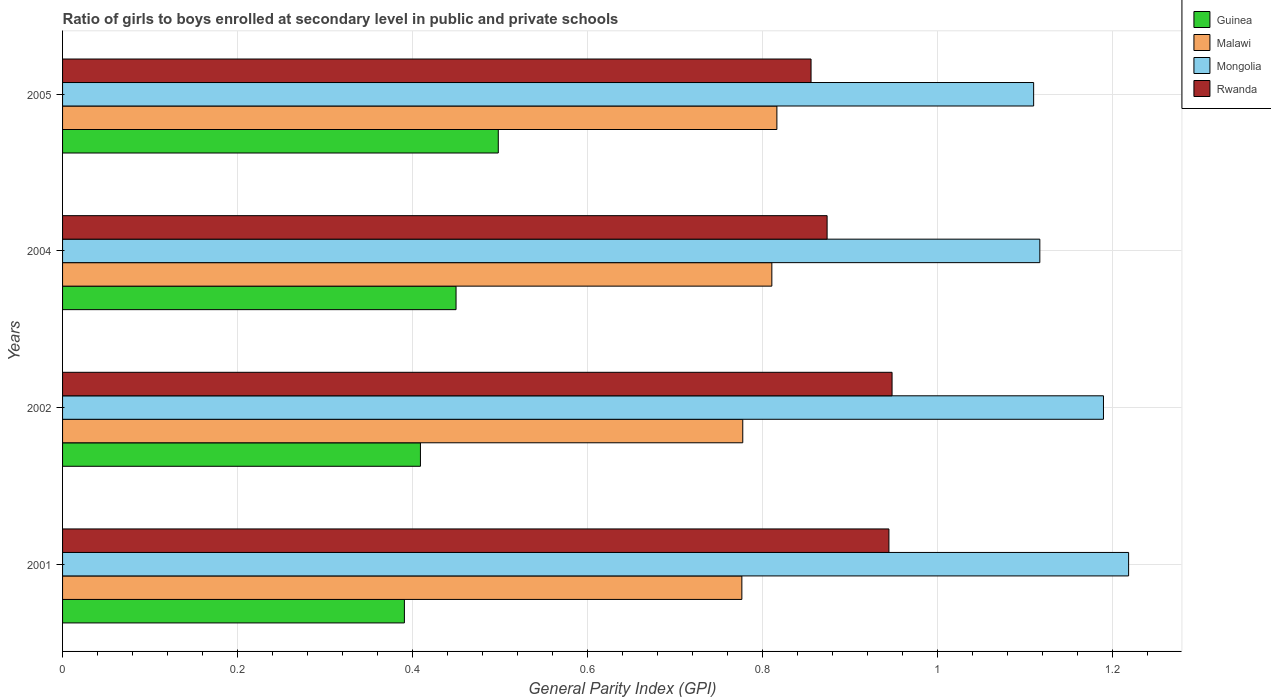How many different coloured bars are there?
Your response must be concise. 4. Are the number of bars per tick equal to the number of legend labels?
Your answer should be compact. Yes. How many bars are there on the 3rd tick from the top?
Make the answer very short. 4. In how many cases, is the number of bars for a given year not equal to the number of legend labels?
Provide a short and direct response. 0. What is the general parity index in Guinea in 2005?
Make the answer very short. 0.5. Across all years, what is the maximum general parity index in Mongolia?
Provide a short and direct response. 1.22. Across all years, what is the minimum general parity index in Mongolia?
Your answer should be very brief. 1.11. In which year was the general parity index in Guinea maximum?
Ensure brevity in your answer.  2005. What is the total general parity index in Guinea in the graph?
Keep it short and to the point. 1.75. What is the difference between the general parity index in Guinea in 2002 and that in 2005?
Ensure brevity in your answer.  -0.09. What is the difference between the general parity index in Mongolia in 2004 and the general parity index in Guinea in 2005?
Provide a short and direct response. 0.62. What is the average general parity index in Rwanda per year?
Keep it short and to the point. 0.91. In the year 2001, what is the difference between the general parity index in Malawi and general parity index in Guinea?
Provide a short and direct response. 0.39. In how many years, is the general parity index in Malawi greater than 0.16 ?
Offer a very short reply. 4. What is the ratio of the general parity index in Guinea in 2001 to that in 2004?
Your response must be concise. 0.87. What is the difference between the highest and the second highest general parity index in Guinea?
Offer a very short reply. 0.05. What is the difference between the highest and the lowest general parity index in Rwanda?
Give a very brief answer. 0.09. In how many years, is the general parity index in Rwanda greater than the average general parity index in Rwanda taken over all years?
Your answer should be very brief. 2. Is the sum of the general parity index in Mongolia in 2002 and 2004 greater than the maximum general parity index in Rwanda across all years?
Make the answer very short. Yes. Is it the case that in every year, the sum of the general parity index in Guinea and general parity index in Malawi is greater than the sum of general parity index in Rwanda and general parity index in Mongolia?
Make the answer very short. Yes. What does the 4th bar from the top in 2004 represents?
Ensure brevity in your answer.  Guinea. What does the 2nd bar from the bottom in 2001 represents?
Your answer should be compact. Malawi. How many bars are there?
Your response must be concise. 16. How many years are there in the graph?
Provide a short and direct response. 4. Are the values on the major ticks of X-axis written in scientific E-notation?
Offer a terse response. No. Does the graph contain any zero values?
Offer a terse response. No. Where does the legend appear in the graph?
Offer a very short reply. Top right. How many legend labels are there?
Offer a very short reply. 4. How are the legend labels stacked?
Ensure brevity in your answer.  Vertical. What is the title of the graph?
Your answer should be very brief. Ratio of girls to boys enrolled at secondary level in public and private schools. Does "West Bank and Gaza" appear as one of the legend labels in the graph?
Keep it short and to the point. No. What is the label or title of the X-axis?
Provide a short and direct response. General Parity Index (GPI). What is the label or title of the Y-axis?
Keep it short and to the point. Years. What is the General Parity Index (GPI) in Guinea in 2001?
Give a very brief answer. 0.39. What is the General Parity Index (GPI) in Malawi in 2001?
Ensure brevity in your answer.  0.78. What is the General Parity Index (GPI) in Mongolia in 2001?
Offer a very short reply. 1.22. What is the General Parity Index (GPI) in Rwanda in 2001?
Provide a succinct answer. 0.94. What is the General Parity Index (GPI) of Guinea in 2002?
Keep it short and to the point. 0.41. What is the General Parity Index (GPI) of Malawi in 2002?
Your response must be concise. 0.78. What is the General Parity Index (GPI) of Mongolia in 2002?
Your answer should be very brief. 1.19. What is the General Parity Index (GPI) of Rwanda in 2002?
Provide a succinct answer. 0.95. What is the General Parity Index (GPI) in Guinea in 2004?
Give a very brief answer. 0.45. What is the General Parity Index (GPI) in Malawi in 2004?
Offer a very short reply. 0.81. What is the General Parity Index (GPI) in Mongolia in 2004?
Keep it short and to the point. 1.12. What is the General Parity Index (GPI) in Rwanda in 2004?
Offer a very short reply. 0.87. What is the General Parity Index (GPI) in Guinea in 2005?
Offer a terse response. 0.5. What is the General Parity Index (GPI) in Malawi in 2005?
Ensure brevity in your answer.  0.82. What is the General Parity Index (GPI) of Mongolia in 2005?
Offer a terse response. 1.11. What is the General Parity Index (GPI) of Rwanda in 2005?
Your answer should be very brief. 0.86. Across all years, what is the maximum General Parity Index (GPI) in Guinea?
Provide a short and direct response. 0.5. Across all years, what is the maximum General Parity Index (GPI) in Malawi?
Make the answer very short. 0.82. Across all years, what is the maximum General Parity Index (GPI) of Mongolia?
Your response must be concise. 1.22. Across all years, what is the maximum General Parity Index (GPI) in Rwanda?
Your answer should be compact. 0.95. Across all years, what is the minimum General Parity Index (GPI) of Guinea?
Offer a very short reply. 0.39. Across all years, what is the minimum General Parity Index (GPI) in Malawi?
Keep it short and to the point. 0.78. Across all years, what is the minimum General Parity Index (GPI) in Mongolia?
Provide a succinct answer. 1.11. Across all years, what is the minimum General Parity Index (GPI) in Rwanda?
Offer a terse response. 0.86. What is the total General Parity Index (GPI) in Guinea in the graph?
Ensure brevity in your answer.  1.75. What is the total General Parity Index (GPI) in Malawi in the graph?
Provide a short and direct response. 3.18. What is the total General Parity Index (GPI) in Mongolia in the graph?
Provide a short and direct response. 4.63. What is the total General Parity Index (GPI) in Rwanda in the graph?
Provide a short and direct response. 3.62. What is the difference between the General Parity Index (GPI) of Guinea in 2001 and that in 2002?
Make the answer very short. -0.02. What is the difference between the General Parity Index (GPI) of Malawi in 2001 and that in 2002?
Keep it short and to the point. -0. What is the difference between the General Parity Index (GPI) in Mongolia in 2001 and that in 2002?
Give a very brief answer. 0.03. What is the difference between the General Parity Index (GPI) of Rwanda in 2001 and that in 2002?
Make the answer very short. -0. What is the difference between the General Parity Index (GPI) in Guinea in 2001 and that in 2004?
Provide a succinct answer. -0.06. What is the difference between the General Parity Index (GPI) of Malawi in 2001 and that in 2004?
Make the answer very short. -0.03. What is the difference between the General Parity Index (GPI) in Mongolia in 2001 and that in 2004?
Provide a succinct answer. 0.1. What is the difference between the General Parity Index (GPI) in Rwanda in 2001 and that in 2004?
Provide a succinct answer. 0.07. What is the difference between the General Parity Index (GPI) of Guinea in 2001 and that in 2005?
Your answer should be very brief. -0.11. What is the difference between the General Parity Index (GPI) of Malawi in 2001 and that in 2005?
Ensure brevity in your answer.  -0.04. What is the difference between the General Parity Index (GPI) of Mongolia in 2001 and that in 2005?
Your response must be concise. 0.11. What is the difference between the General Parity Index (GPI) in Rwanda in 2001 and that in 2005?
Your response must be concise. 0.09. What is the difference between the General Parity Index (GPI) in Guinea in 2002 and that in 2004?
Your answer should be compact. -0.04. What is the difference between the General Parity Index (GPI) in Malawi in 2002 and that in 2004?
Offer a very short reply. -0.03. What is the difference between the General Parity Index (GPI) of Mongolia in 2002 and that in 2004?
Make the answer very short. 0.07. What is the difference between the General Parity Index (GPI) of Rwanda in 2002 and that in 2004?
Offer a terse response. 0.07. What is the difference between the General Parity Index (GPI) in Guinea in 2002 and that in 2005?
Your answer should be very brief. -0.09. What is the difference between the General Parity Index (GPI) in Malawi in 2002 and that in 2005?
Make the answer very short. -0.04. What is the difference between the General Parity Index (GPI) in Mongolia in 2002 and that in 2005?
Provide a short and direct response. 0.08. What is the difference between the General Parity Index (GPI) of Rwanda in 2002 and that in 2005?
Your answer should be compact. 0.09. What is the difference between the General Parity Index (GPI) of Guinea in 2004 and that in 2005?
Your answer should be compact. -0.05. What is the difference between the General Parity Index (GPI) of Malawi in 2004 and that in 2005?
Provide a succinct answer. -0.01. What is the difference between the General Parity Index (GPI) in Mongolia in 2004 and that in 2005?
Give a very brief answer. 0.01. What is the difference between the General Parity Index (GPI) in Rwanda in 2004 and that in 2005?
Provide a succinct answer. 0.02. What is the difference between the General Parity Index (GPI) of Guinea in 2001 and the General Parity Index (GPI) of Malawi in 2002?
Provide a succinct answer. -0.39. What is the difference between the General Parity Index (GPI) in Guinea in 2001 and the General Parity Index (GPI) in Mongolia in 2002?
Your answer should be compact. -0.8. What is the difference between the General Parity Index (GPI) of Guinea in 2001 and the General Parity Index (GPI) of Rwanda in 2002?
Offer a very short reply. -0.56. What is the difference between the General Parity Index (GPI) in Malawi in 2001 and the General Parity Index (GPI) in Mongolia in 2002?
Provide a succinct answer. -0.41. What is the difference between the General Parity Index (GPI) in Malawi in 2001 and the General Parity Index (GPI) in Rwanda in 2002?
Your answer should be compact. -0.17. What is the difference between the General Parity Index (GPI) in Mongolia in 2001 and the General Parity Index (GPI) in Rwanda in 2002?
Ensure brevity in your answer.  0.27. What is the difference between the General Parity Index (GPI) in Guinea in 2001 and the General Parity Index (GPI) in Malawi in 2004?
Your response must be concise. -0.42. What is the difference between the General Parity Index (GPI) in Guinea in 2001 and the General Parity Index (GPI) in Mongolia in 2004?
Keep it short and to the point. -0.73. What is the difference between the General Parity Index (GPI) of Guinea in 2001 and the General Parity Index (GPI) of Rwanda in 2004?
Make the answer very short. -0.48. What is the difference between the General Parity Index (GPI) of Malawi in 2001 and the General Parity Index (GPI) of Mongolia in 2004?
Your answer should be very brief. -0.34. What is the difference between the General Parity Index (GPI) of Malawi in 2001 and the General Parity Index (GPI) of Rwanda in 2004?
Offer a very short reply. -0.1. What is the difference between the General Parity Index (GPI) in Mongolia in 2001 and the General Parity Index (GPI) in Rwanda in 2004?
Your response must be concise. 0.34. What is the difference between the General Parity Index (GPI) in Guinea in 2001 and the General Parity Index (GPI) in Malawi in 2005?
Ensure brevity in your answer.  -0.43. What is the difference between the General Parity Index (GPI) in Guinea in 2001 and the General Parity Index (GPI) in Mongolia in 2005?
Make the answer very short. -0.72. What is the difference between the General Parity Index (GPI) of Guinea in 2001 and the General Parity Index (GPI) of Rwanda in 2005?
Ensure brevity in your answer.  -0.46. What is the difference between the General Parity Index (GPI) in Malawi in 2001 and the General Parity Index (GPI) in Mongolia in 2005?
Offer a terse response. -0.33. What is the difference between the General Parity Index (GPI) in Malawi in 2001 and the General Parity Index (GPI) in Rwanda in 2005?
Keep it short and to the point. -0.08. What is the difference between the General Parity Index (GPI) of Mongolia in 2001 and the General Parity Index (GPI) of Rwanda in 2005?
Make the answer very short. 0.36. What is the difference between the General Parity Index (GPI) of Guinea in 2002 and the General Parity Index (GPI) of Malawi in 2004?
Your answer should be very brief. -0.4. What is the difference between the General Parity Index (GPI) in Guinea in 2002 and the General Parity Index (GPI) in Mongolia in 2004?
Ensure brevity in your answer.  -0.71. What is the difference between the General Parity Index (GPI) in Guinea in 2002 and the General Parity Index (GPI) in Rwanda in 2004?
Provide a succinct answer. -0.46. What is the difference between the General Parity Index (GPI) in Malawi in 2002 and the General Parity Index (GPI) in Mongolia in 2004?
Your answer should be compact. -0.34. What is the difference between the General Parity Index (GPI) of Malawi in 2002 and the General Parity Index (GPI) of Rwanda in 2004?
Your answer should be very brief. -0.1. What is the difference between the General Parity Index (GPI) in Mongolia in 2002 and the General Parity Index (GPI) in Rwanda in 2004?
Your answer should be compact. 0.32. What is the difference between the General Parity Index (GPI) in Guinea in 2002 and the General Parity Index (GPI) in Malawi in 2005?
Your answer should be compact. -0.41. What is the difference between the General Parity Index (GPI) in Guinea in 2002 and the General Parity Index (GPI) in Mongolia in 2005?
Give a very brief answer. -0.7. What is the difference between the General Parity Index (GPI) of Guinea in 2002 and the General Parity Index (GPI) of Rwanda in 2005?
Make the answer very short. -0.45. What is the difference between the General Parity Index (GPI) in Malawi in 2002 and the General Parity Index (GPI) in Mongolia in 2005?
Provide a short and direct response. -0.33. What is the difference between the General Parity Index (GPI) in Malawi in 2002 and the General Parity Index (GPI) in Rwanda in 2005?
Provide a short and direct response. -0.08. What is the difference between the General Parity Index (GPI) of Mongolia in 2002 and the General Parity Index (GPI) of Rwanda in 2005?
Offer a terse response. 0.33. What is the difference between the General Parity Index (GPI) of Guinea in 2004 and the General Parity Index (GPI) of Malawi in 2005?
Provide a short and direct response. -0.37. What is the difference between the General Parity Index (GPI) of Guinea in 2004 and the General Parity Index (GPI) of Mongolia in 2005?
Give a very brief answer. -0.66. What is the difference between the General Parity Index (GPI) in Guinea in 2004 and the General Parity Index (GPI) in Rwanda in 2005?
Offer a terse response. -0.41. What is the difference between the General Parity Index (GPI) of Malawi in 2004 and the General Parity Index (GPI) of Mongolia in 2005?
Ensure brevity in your answer.  -0.3. What is the difference between the General Parity Index (GPI) of Malawi in 2004 and the General Parity Index (GPI) of Rwanda in 2005?
Your answer should be compact. -0.04. What is the difference between the General Parity Index (GPI) in Mongolia in 2004 and the General Parity Index (GPI) in Rwanda in 2005?
Provide a succinct answer. 0.26. What is the average General Parity Index (GPI) in Guinea per year?
Keep it short and to the point. 0.44. What is the average General Parity Index (GPI) in Malawi per year?
Offer a very short reply. 0.8. What is the average General Parity Index (GPI) of Mongolia per year?
Offer a very short reply. 1.16. What is the average General Parity Index (GPI) in Rwanda per year?
Give a very brief answer. 0.91. In the year 2001, what is the difference between the General Parity Index (GPI) in Guinea and General Parity Index (GPI) in Malawi?
Offer a terse response. -0.39. In the year 2001, what is the difference between the General Parity Index (GPI) of Guinea and General Parity Index (GPI) of Mongolia?
Make the answer very short. -0.83. In the year 2001, what is the difference between the General Parity Index (GPI) in Guinea and General Parity Index (GPI) in Rwanda?
Your response must be concise. -0.55. In the year 2001, what is the difference between the General Parity Index (GPI) of Malawi and General Parity Index (GPI) of Mongolia?
Provide a short and direct response. -0.44. In the year 2001, what is the difference between the General Parity Index (GPI) of Malawi and General Parity Index (GPI) of Rwanda?
Your response must be concise. -0.17. In the year 2001, what is the difference between the General Parity Index (GPI) in Mongolia and General Parity Index (GPI) in Rwanda?
Provide a short and direct response. 0.27. In the year 2002, what is the difference between the General Parity Index (GPI) of Guinea and General Parity Index (GPI) of Malawi?
Keep it short and to the point. -0.37. In the year 2002, what is the difference between the General Parity Index (GPI) of Guinea and General Parity Index (GPI) of Mongolia?
Make the answer very short. -0.78. In the year 2002, what is the difference between the General Parity Index (GPI) of Guinea and General Parity Index (GPI) of Rwanda?
Your response must be concise. -0.54. In the year 2002, what is the difference between the General Parity Index (GPI) in Malawi and General Parity Index (GPI) in Mongolia?
Your response must be concise. -0.41. In the year 2002, what is the difference between the General Parity Index (GPI) in Malawi and General Parity Index (GPI) in Rwanda?
Keep it short and to the point. -0.17. In the year 2002, what is the difference between the General Parity Index (GPI) of Mongolia and General Parity Index (GPI) of Rwanda?
Ensure brevity in your answer.  0.24. In the year 2004, what is the difference between the General Parity Index (GPI) in Guinea and General Parity Index (GPI) in Malawi?
Offer a very short reply. -0.36. In the year 2004, what is the difference between the General Parity Index (GPI) of Guinea and General Parity Index (GPI) of Mongolia?
Your answer should be very brief. -0.67. In the year 2004, what is the difference between the General Parity Index (GPI) of Guinea and General Parity Index (GPI) of Rwanda?
Offer a terse response. -0.42. In the year 2004, what is the difference between the General Parity Index (GPI) in Malawi and General Parity Index (GPI) in Mongolia?
Keep it short and to the point. -0.31. In the year 2004, what is the difference between the General Parity Index (GPI) in Malawi and General Parity Index (GPI) in Rwanda?
Keep it short and to the point. -0.06. In the year 2004, what is the difference between the General Parity Index (GPI) in Mongolia and General Parity Index (GPI) in Rwanda?
Ensure brevity in your answer.  0.24. In the year 2005, what is the difference between the General Parity Index (GPI) in Guinea and General Parity Index (GPI) in Malawi?
Make the answer very short. -0.32. In the year 2005, what is the difference between the General Parity Index (GPI) in Guinea and General Parity Index (GPI) in Mongolia?
Offer a very short reply. -0.61. In the year 2005, what is the difference between the General Parity Index (GPI) of Guinea and General Parity Index (GPI) of Rwanda?
Keep it short and to the point. -0.36. In the year 2005, what is the difference between the General Parity Index (GPI) in Malawi and General Parity Index (GPI) in Mongolia?
Your answer should be compact. -0.29. In the year 2005, what is the difference between the General Parity Index (GPI) in Malawi and General Parity Index (GPI) in Rwanda?
Your answer should be very brief. -0.04. In the year 2005, what is the difference between the General Parity Index (GPI) in Mongolia and General Parity Index (GPI) in Rwanda?
Offer a very short reply. 0.25. What is the ratio of the General Parity Index (GPI) in Guinea in 2001 to that in 2002?
Your answer should be compact. 0.96. What is the ratio of the General Parity Index (GPI) in Mongolia in 2001 to that in 2002?
Your response must be concise. 1.02. What is the ratio of the General Parity Index (GPI) in Rwanda in 2001 to that in 2002?
Your response must be concise. 1. What is the ratio of the General Parity Index (GPI) in Guinea in 2001 to that in 2004?
Make the answer very short. 0.87. What is the ratio of the General Parity Index (GPI) in Malawi in 2001 to that in 2004?
Make the answer very short. 0.96. What is the ratio of the General Parity Index (GPI) in Rwanda in 2001 to that in 2004?
Keep it short and to the point. 1.08. What is the ratio of the General Parity Index (GPI) of Guinea in 2001 to that in 2005?
Keep it short and to the point. 0.78. What is the ratio of the General Parity Index (GPI) in Malawi in 2001 to that in 2005?
Offer a terse response. 0.95. What is the ratio of the General Parity Index (GPI) in Mongolia in 2001 to that in 2005?
Your answer should be compact. 1.1. What is the ratio of the General Parity Index (GPI) of Rwanda in 2001 to that in 2005?
Your answer should be very brief. 1.1. What is the ratio of the General Parity Index (GPI) in Guinea in 2002 to that in 2004?
Give a very brief answer. 0.91. What is the ratio of the General Parity Index (GPI) of Mongolia in 2002 to that in 2004?
Offer a terse response. 1.07. What is the ratio of the General Parity Index (GPI) of Rwanda in 2002 to that in 2004?
Offer a very short reply. 1.08. What is the ratio of the General Parity Index (GPI) in Guinea in 2002 to that in 2005?
Your answer should be very brief. 0.82. What is the ratio of the General Parity Index (GPI) in Malawi in 2002 to that in 2005?
Provide a short and direct response. 0.95. What is the ratio of the General Parity Index (GPI) of Mongolia in 2002 to that in 2005?
Your response must be concise. 1.07. What is the ratio of the General Parity Index (GPI) of Rwanda in 2002 to that in 2005?
Offer a very short reply. 1.11. What is the ratio of the General Parity Index (GPI) in Guinea in 2004 to that in 2005?
Provide a succinct answer. 0.9. What is the ratio of the General Parity Index (GPI) of Mongolia in 2004 to that in 2005?
Provide a short and direct response. 1.01. What is the ratio of the General Parity Index (GPI) in Rwanda in 2004 to that in 2005?
Your answer should be very brief. 1.02. What is the difference between the highest and the second highest General Parity Index (GPI) of Guinea?
Ensure brevity in your answer.  0.05. What is the difference between the highest and the second highest General Parity Index (GPI) in Malawi?
Provide a succinct answer. 0.01. What is the difference between the highest and the second highest General Parity Index (GPI) in Mongolia?
Your response must be concise. 0.03. What is the difference between the highest and the second highest General Parity Index (GPI) in Rwanda?
Provide a short and direct response. 0. What is the difference between the highest and the lowest General Parity Index (GPI) of Guinea?
Your response must be concise. 0.11. What is the difference between the highest and the lowest General Parity Index (GPI) in Malawi?
Offer a terse response. 0.04. What is the difference between the highest and the lowest General Parity Index (GPI) in Mongolia?
Your response must be concise. 0.11. What is the difference between the highest and the lowest General Parity Index (GPI) of Rwanda?
Provide a succinct answer. 0.09. 